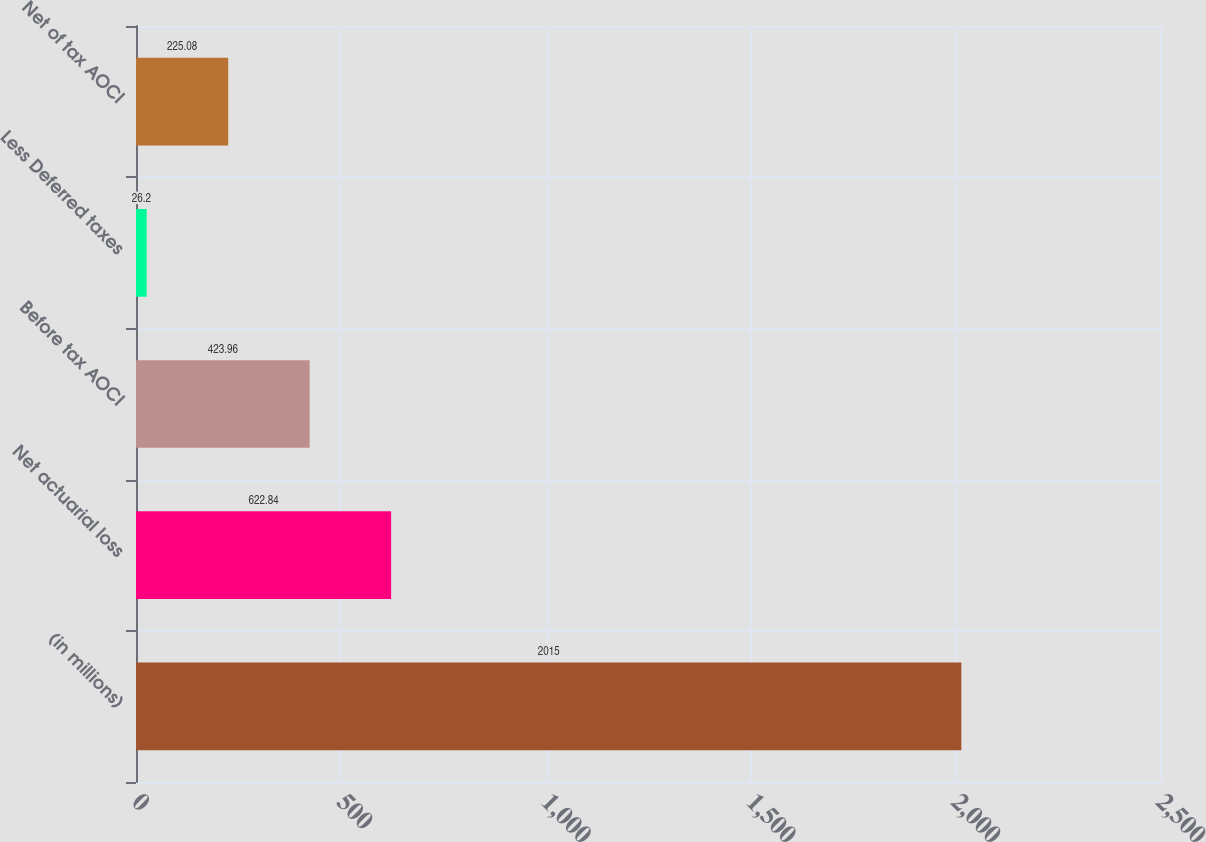Convert chart to OTSL. <chart><loc_0><loc_0><loc_500><loc_500><bar_chart><fcel>(in millions)<fcel>Net actuarial loss<fcel>Before tax AOCI<fcel>Less Deferred taxes<fcel>Net of tax AOCI<nl><fcel>2015<fcel>622.84<fcel>423.96<fcel>26.2<fcel>225.08<nl></chart> 